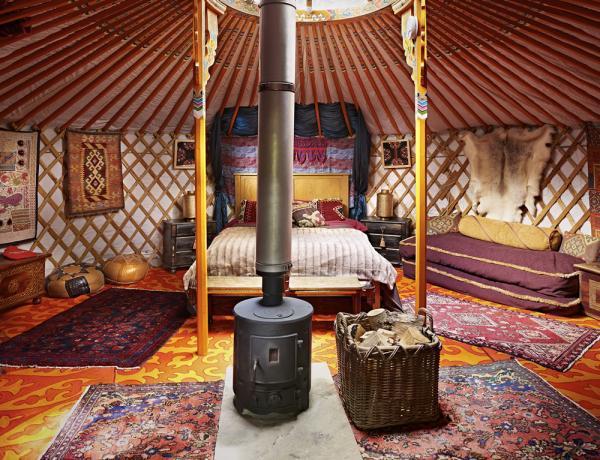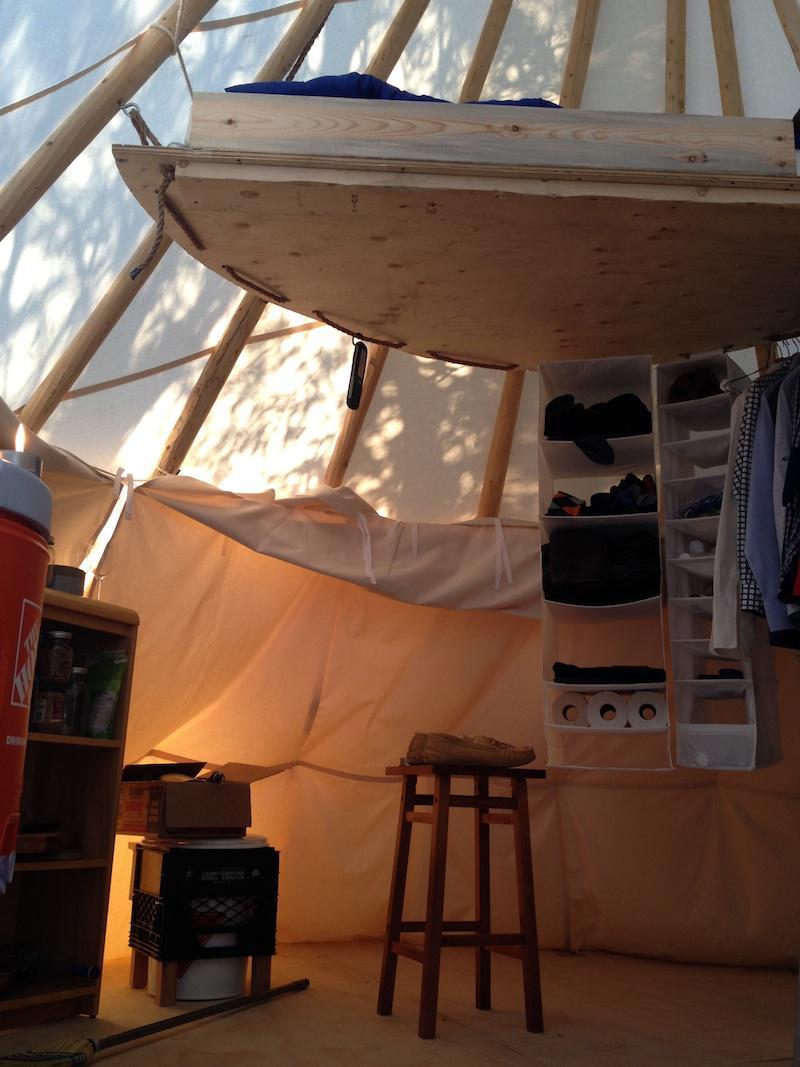The first image is the image on the left, the second image is the image on the right. Evaluate the accuracy of this statement regarding the images: "In one image, a stainless steel refrigerator is in the kitchen area of a yurt, while a second image shows a bedroom area.". Is it true? Answer yes or no. No. The first image is the image on the left, the second image is the image on the right. Evaluate the accuracy of this statement regarding the images: "The refridgerator is set up near the wall of a tent.". Is it true? Answer yes or no. No. 